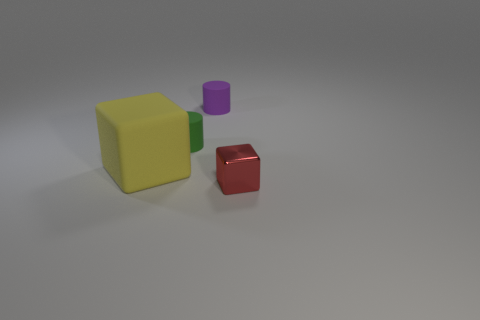Add 1 small red shiny cubes. How many objects exist? 5 Add 3 matte cylinders. How many matte cylinders exist? 5 Subtract 0 blue cubes. How many objects are left? 4 Subtract all yellow things. Subtract all small green matte cylinders. How many objects are left? 2 Add 4 red metallic objects. How many red metallic objects are left? 5 